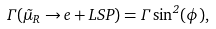Convert formula to latex. <formula><loc_0><loc_0><loc_500><loc_500>\Gamma ( \tilde { \mu } _ { R } \rightarrow e + L S P ) = \Gamma \sin ^ { 2 } ( \phi ) , \,</formula> 